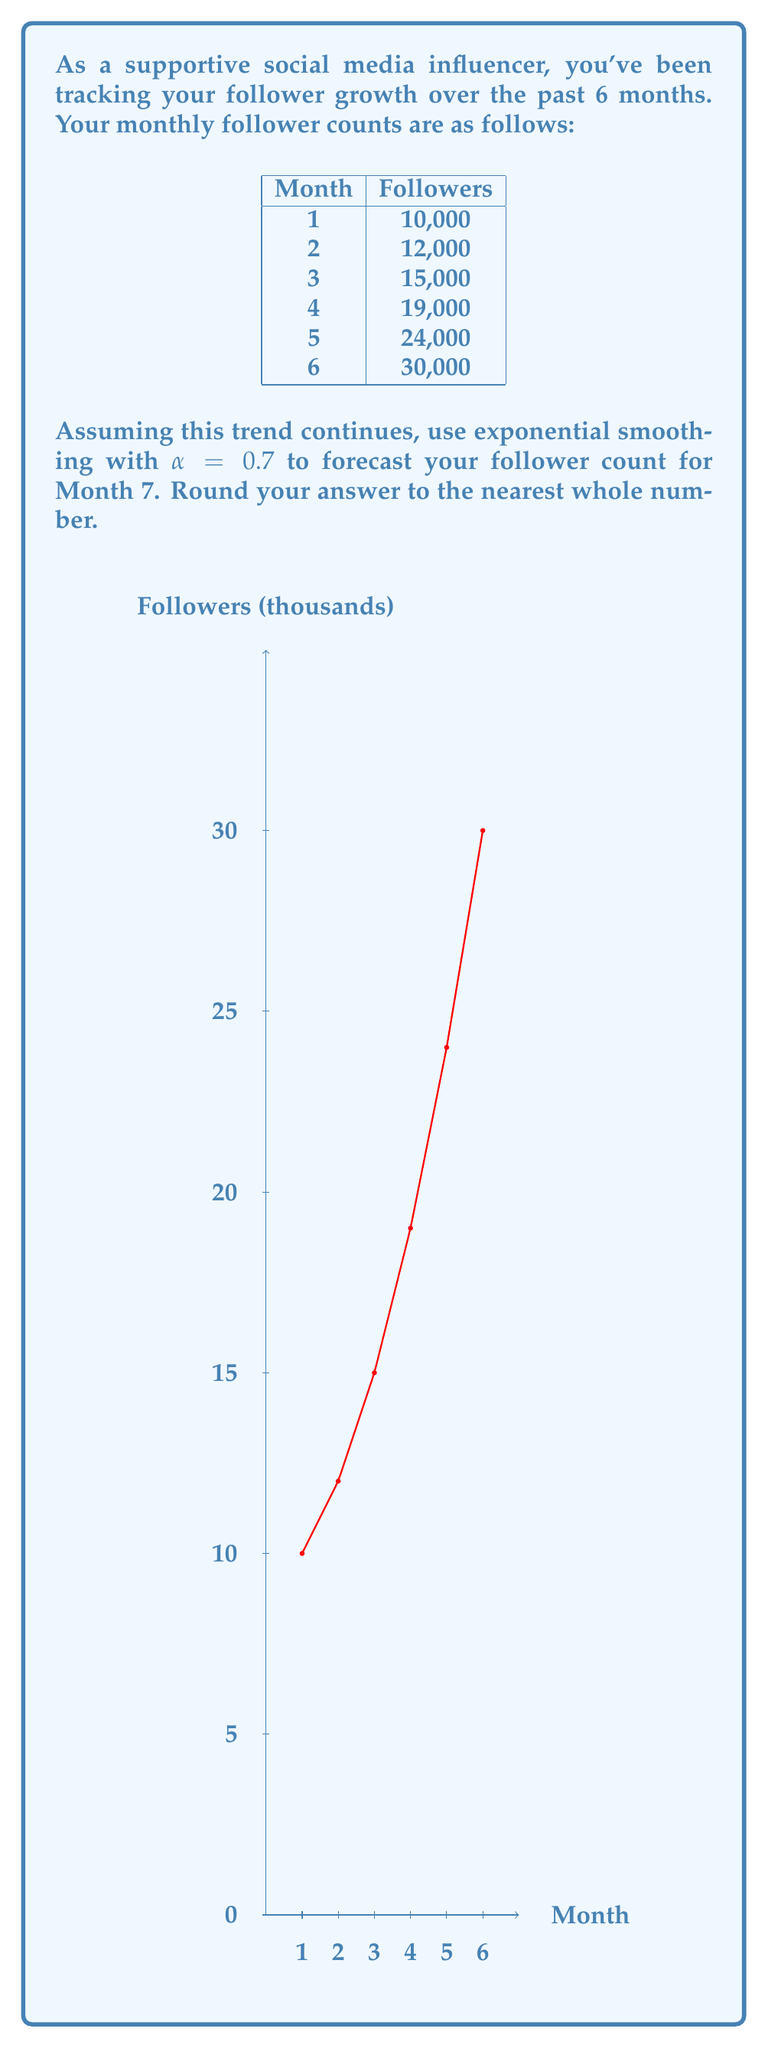Provide a solution to this math problem. To forecast the follower count for Month 7 using exponential smoothing, we'll use the formula:

$$F_{t+1} = \alpha Y_t + (1-\alpha)F_t$$

Where:
$F_{t+1}$ is the forecast for the next period
$\alpha$ is the smoothing factor (0.7 in this case)
$Y_t$ is the actual value for the current period
$F_t$ is the forecast for the current period

We'll start by calculating the forecast for each month:

1. Month 1: No forecast (initial value)
2. Month 2: $F_2 = 0.7 \cdot 10,000 + 0.3 \cdot 10,000 = 10,000$
3. Month 3: $F_3 = 0.7 \cdot 12,000 + 0.3 \cdot 10,000 = 11,400$
4. Month 4: $F_4 = 0.7 \cdot 15,000 + 0.3 \cdot 11,400 = 13,920$
5. Month 5: $F_5 = 0.7 \cdot 19,000 + 0.3 \cdot 13,920 = 17,476$
6. Month 6: $F_6 = 0.7 \cdot 24,000 + 0.3 \cdot 17,476 = 21,843$

Now, we can forecast Month 7:

$$F_7 = 0.7 \cdot 30,000 + 0.3 \cdot 21,843 = 27,553$$

Rounding to the nearest whole number, we get 27,553.
Answer: 27,553 followers 